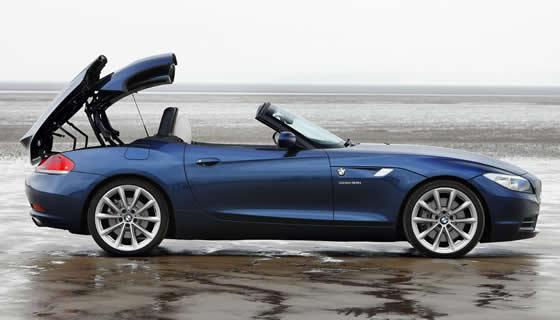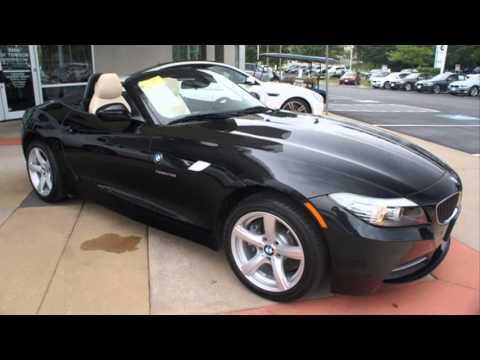The first image is the image on the left, the second image is the image on the right. Evaluate the accuracy of this statement regarding the images: "In one image, a blue car is shown with its hard roof being lowered into the trunk area.". Is it true? Answer yes or no. Yes. 